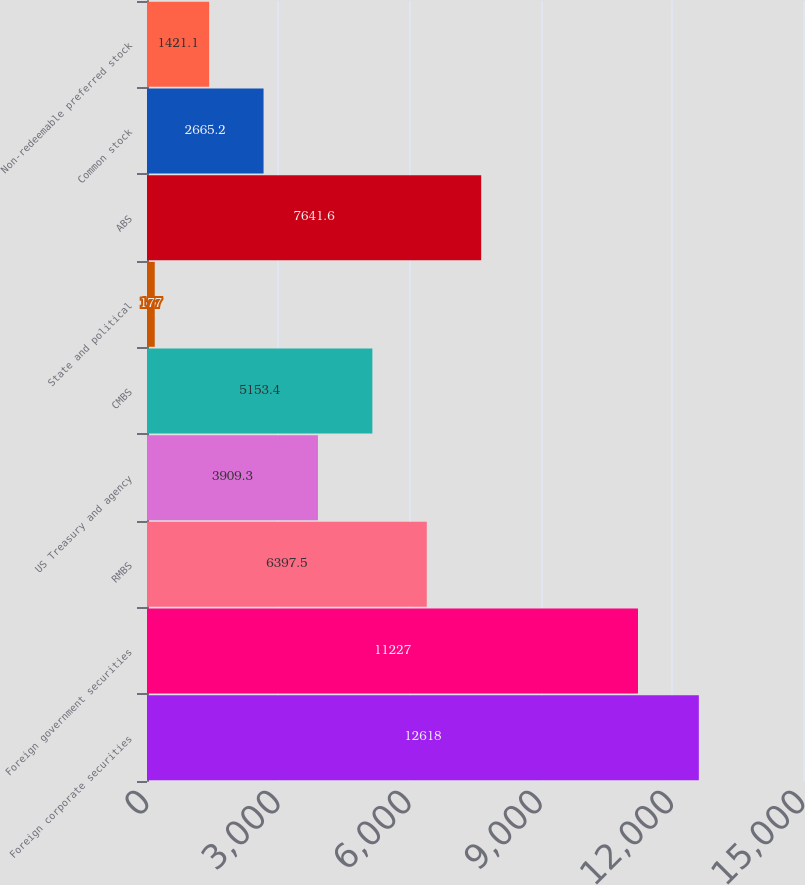<chart> <loc_0><loc_0><loc_500><loc_500><bar_chart><fcel>Foreign corporate securities<fcel>Foreign government securities<fcel>RMBS<fcel>US Treasury and agency<fcel>CMBS<fcel>State and political<fcel>ABS<fcel>Common stock<fcel>Non-redeemable preferred stock<nl><fcel>12618<fcel>11227<fcel>6397.5<fcel>3909.3<fcel>5153.4<fcel>177<fcel>7641.6<fcel>2665.2<fcel>1421.1<nl></chart> 